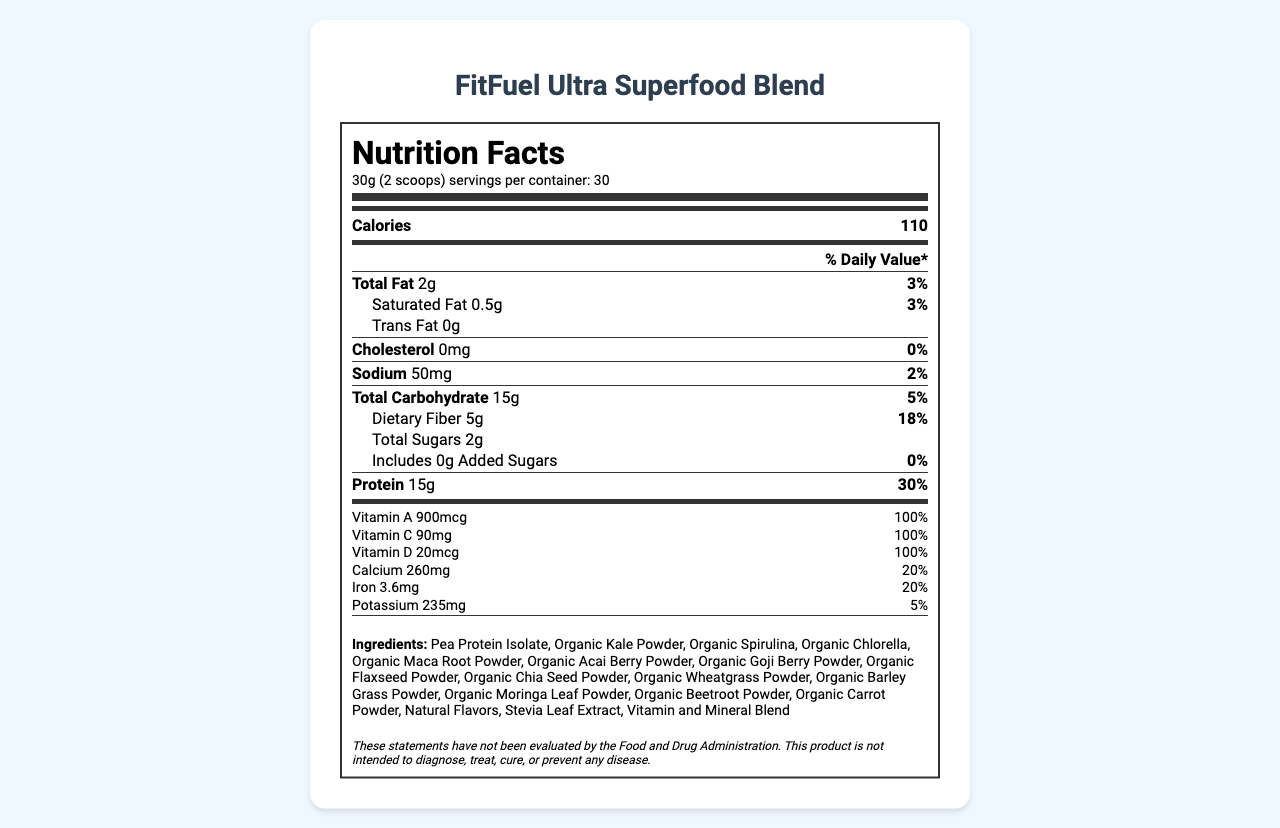what is the serving size of FitFuel Ultra Superfood Blend? The document lists the serving size as 30g (2 scoops) in the Nutrition Facts section.
Answer: 30g (2 scoops) how many servings are there per container of FitFuel Ultra Superfood Blend? The document specifies that there are 30 servings per container.
Answer: 30 servings how many calories are in one serving of FitFuel Ultra Superfood Blend? The document states that one serving contains 110 calories.
Answer: 110 calories what is the total fat content per serving? The document indicates that each serving contains 2g of total fat.
Answer: 2g how much dietary fiber does one serving contain and what percentage of the daily value does it represent? The document shows that one serving contains 5g of dietary fiber, which is 18% of the daily value.
Answer: 5g, 18% how much protein does one serving provide and what percentage of the daily value is this? The document states that one serving provides 15g of protein, representing 30% of the daily value.
Answer: 15g, 30% how many total sugars are included per serving, and how much of these are added sugars? The document specifies that there are 2g of total sugars per serving, with 0g of added sugars.
Answer: Total sugars: 2g, Added sugars: 0g does FitFuel Ultra Superfood Blend contain any cholesterol? The document lists the cholesterol content as 0mg, indicating that there is no cholesterol in the product.
Answer: No what is the sodium content per serving and its daily value percentage? The document shows that the sodium content per serving is 50mg, which is 2% of the daily value.
Answer: 50mg, 2% which vitamins provide 100% of the daily value in one serving? (Select all that apply) A. Vitamin A B. Vitamin C C. Vitamin D D. Vitamin E E. Vitamin K All the listed vitamins (A, C, D, E, and K) provide 100% of the daily value per serving according to the document.
Answer: A, B, C, D, E how many milligrams of calcium are there per serving? A. 100mg B. 260mg C. 500mg D. 850mg The document specifies that each serving contains 260mg of calcium.
Answer: B is this product suitable for someone with a peanut allergy? The allergen info in the document states that the product is manufactured in a facility that also processes tree nuts, peanuts, soy, and milk, which implies potential cross-contamination.
Answer: No name at least three organic ingredients present in FitFuel Ultra Superfood Blend. The document lists multiple organic ingredients such as Organic Kale Powder, Organic Spirulina, and Organic Chlorella.
Answer: Organic Kale Powder, Organic Spirulina, Organic Chlorella where should FitFuel Ultra Superfood Blend be stored for best freshness after opening? The storage instructions in the document recommend refrigerating the product after opening for best freshness.
Answer: Refrigerate after opening how should FitFuel Ultra Superfood Blend be used? The suggested use section of the document provides these instructions.
Answer: Mix 2 scoops (30g) with 8-10 oz of water, milk, or your favorite beverage, shake well and enjoy. does FitFuel Ultra Superfood Blend contain any artificial sweeteners? The ingredients list includes Stevia Leaf Extract, which is a natural sweetener, indicating no artificial sweeteners.
Answer: No describe the main idea of this document. The main sections include nutritional content per serving, a list of ingredients, allergen information, storage instructions, suggested use, a disclaimer, and manufacturer details.
Answer: The document provides the Nutrition Facts and additional information for FitFuel Ultra Superfood Blend, a low-calorie, nutrient-dense superfood powder marketed to fitness enthusiasts. are there any potential drug interactions with using FitFuel Ultra Superfood Blend? The document does not provide any information about potential drug interactions.
Answer: Cannot be determined what is the percentage daily value of iron per serving? The document indicates that each serving provides 3.6mg of iron, which is 20% of the daily value.
Answer: 20% 